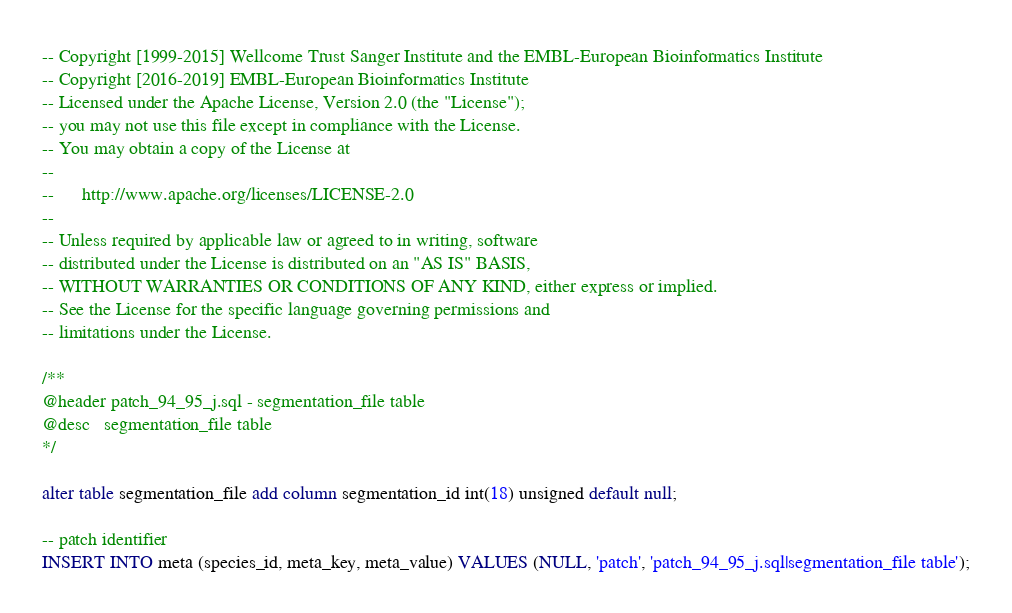Convert code to text. <code><loc_0><loc_0><loc_500><loc_500><_SQL_>-- Copyright [1999-2015] Wellcome Trust Sanger Institute and the EMBL-European Bioinformatics Institute
-- Copyright [2016-2019] EMBL-European Bioinformatics Institute
-- Licensed under the Apache License, Version 2.0 (the "License");
-- you may not use this file except in compliance with the License.
-- You may obtain a copy of the License at
--
--      http://www.apache.org/licenses/LICENSE-2.0
--
-- Unless required by applicable law or agreed to in writing, software
-- distributed under the License is distributed on an "AS IS" BASIS,
-- WITHOUT WARRANTIES OR CONDITIONS OF ANY KIND, either express or implied.
-- See the License for the specific language governing permissions and
-- limitations under the License.

/**
@header patch_94_95_j.sql - segmentation_file table
@desc   segmentation_file table
*/

alter table segmentation_file add column segmentation_id int(18) unsigned default null;

-- patch identifier
INSERT INTO meta (species_id, meta_key, meta_value) VALUES (NULL, 'patch', 'patch_94_95_j.sql|segmentation_file table');
</code> 